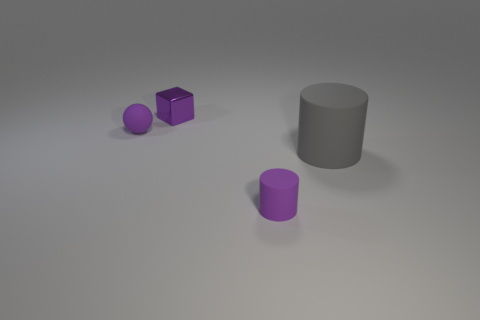Is the size of the gray thing the same as the object on the left side of the purple shiny object?
Provide a short and direct response. No. There is a object that is on the left side of the gray cylinder and to the right of the tiny cube; what color is it?
Your response must be concise. Purple. How many other things are there of the same shape as the purple metal thing?
Ensure brevity in your answer.  0. There is a matte cylinder that is in front of the gray rubber cylinder; is it the same color as the tiny matte thing on the left side of the metal cube?
Give a very brief answer. Yes. There is a thing that is behind the tiny sphere; does it have the same size as the purple matte thing behind the large thing?
Your answer should be very brief. Yes. Is there any other thing that is made of the same material as the purple cylinder?
Give a very brief answer. Yes. What material is the purple object behind the tiny purple rubber object that is behind the tiny matte object in front of the large cylinder?
Your response must be concise. Metal. Is the shape of the shiny thing the same as the big gray rubber object?
Keep it short and to the point. No. There is a purple thing that is the same shape as the gray rubber object; what material is it?
Provide a short and direct response. Rubber. What number of matte objects have the same color as the shiny object?
Give a very brief answer. 2. 